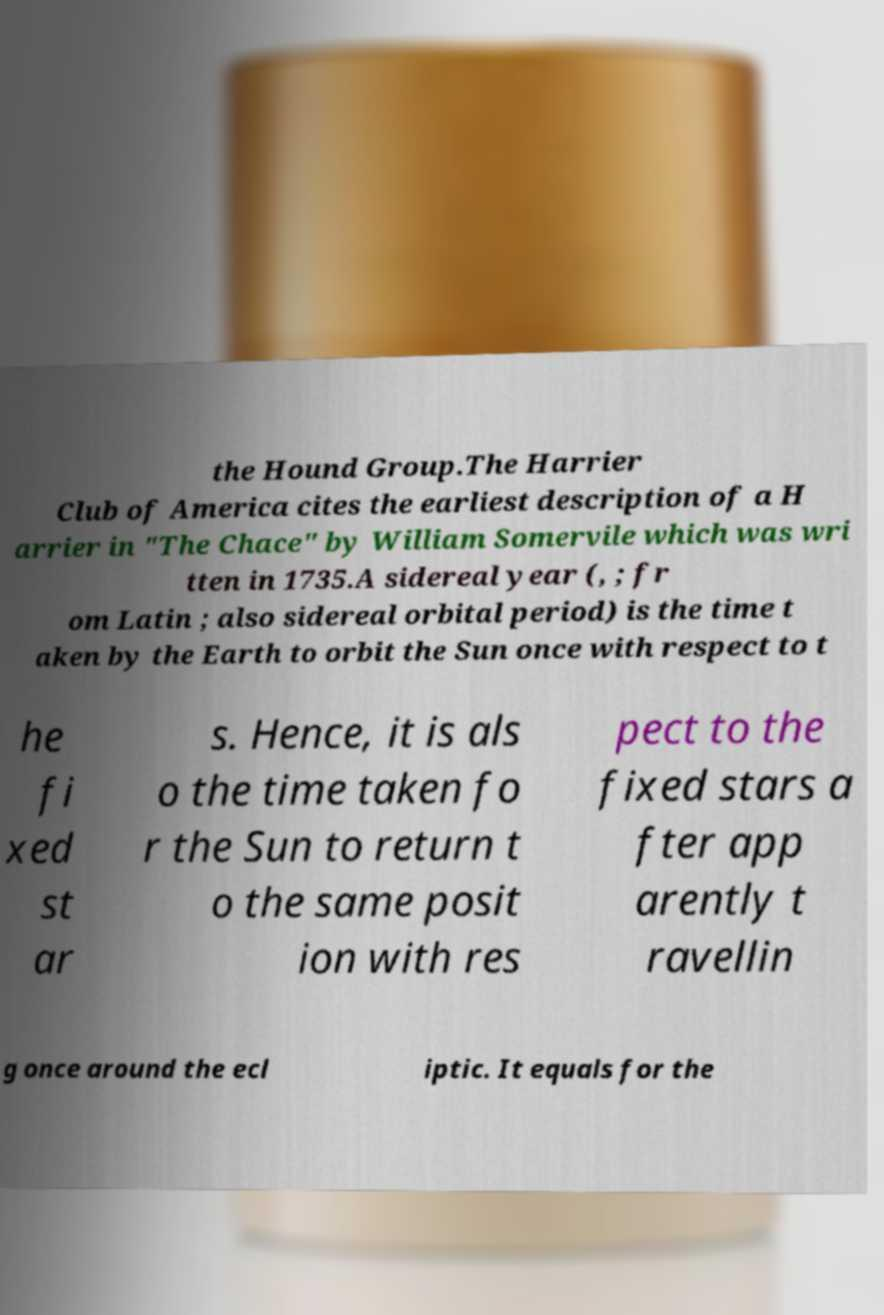Please identify and transcribe the text found in this image. the Hound Group.The Harrier Club of America cites the earliest description of a H arrier in "The Chace" by William Somervile which was wri tten in 1735.A sidereal year (, ; fr om Latin ; also sidereal orbital period) is the time t aken by the Earth to orbit the Sun once with respect to t he fi xed st ar s. Hence, it is als o the time taken fo r the Sun to return t o the same posit ion with res pect to the fixed stars a fter app arently t ravellin g once around the ecl iptic. It equals for the 